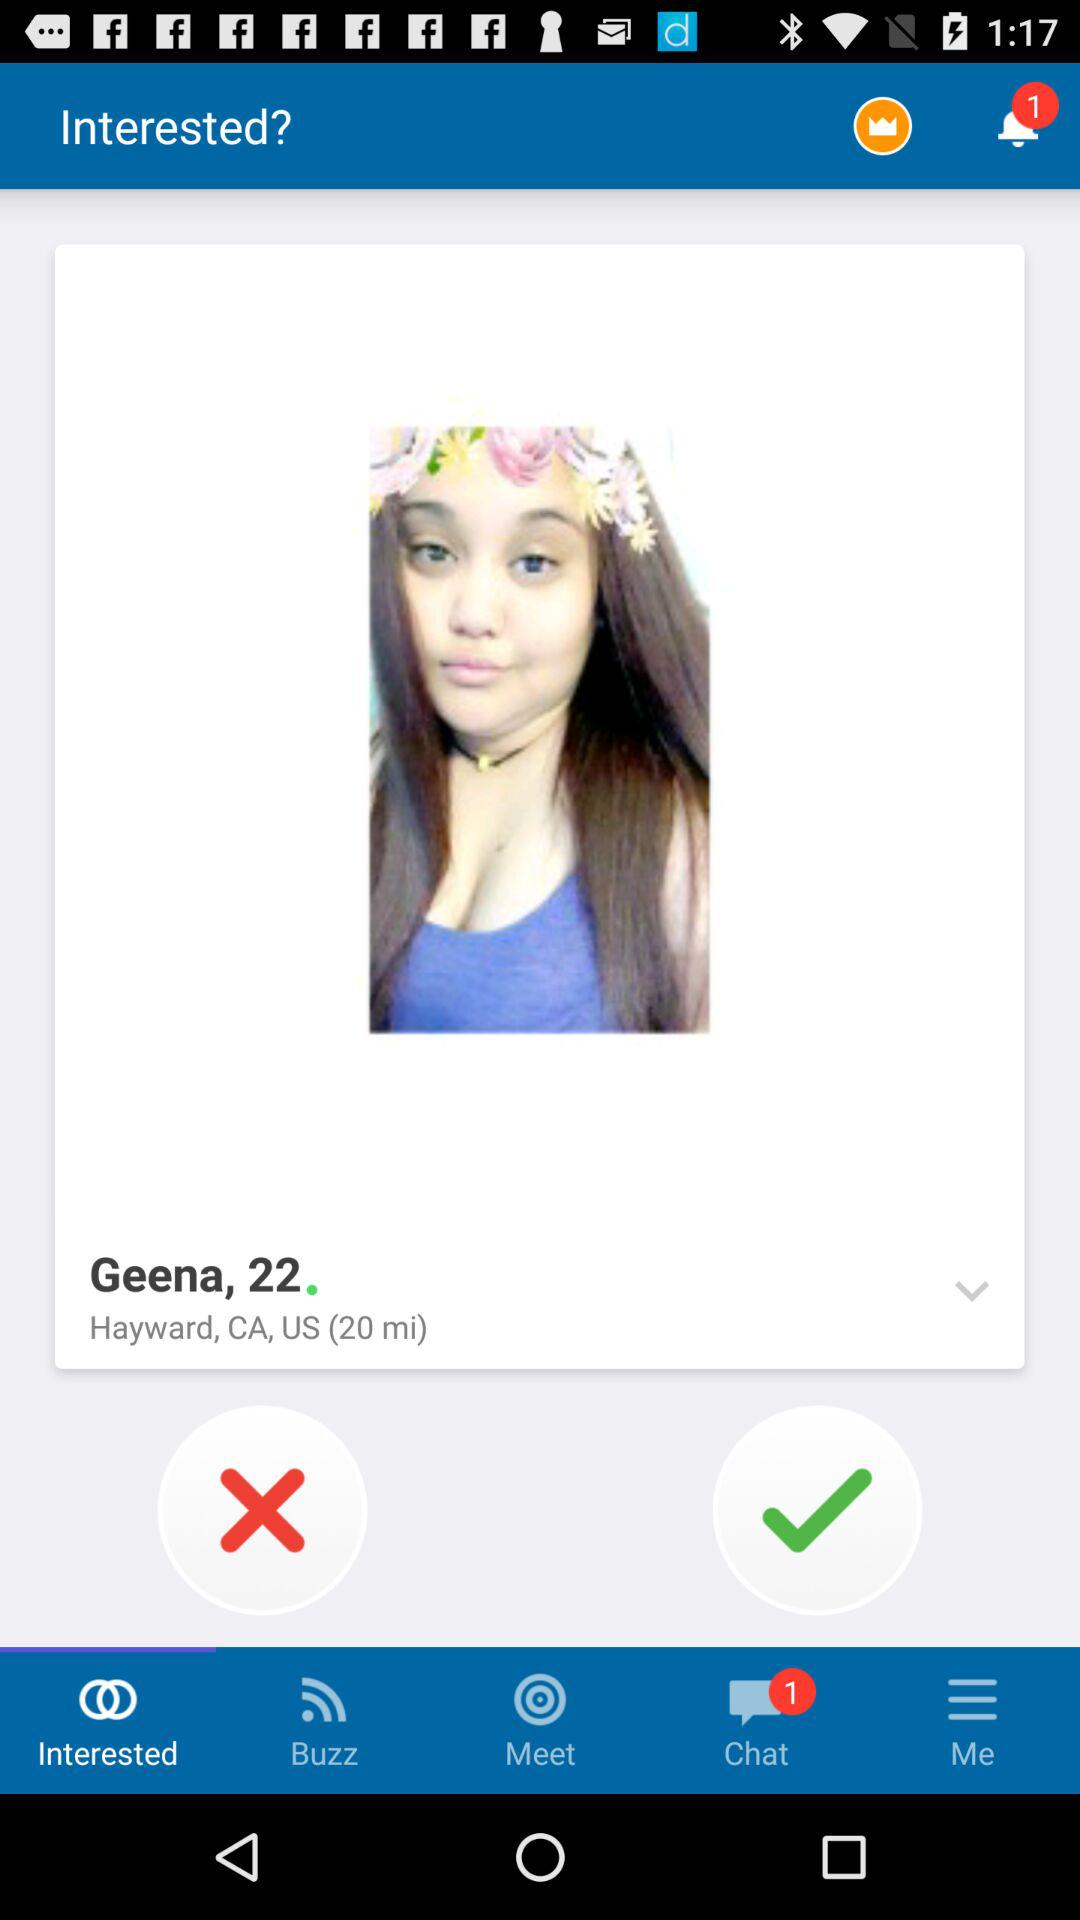What is the location? The location is "Hayward, CA, US". 